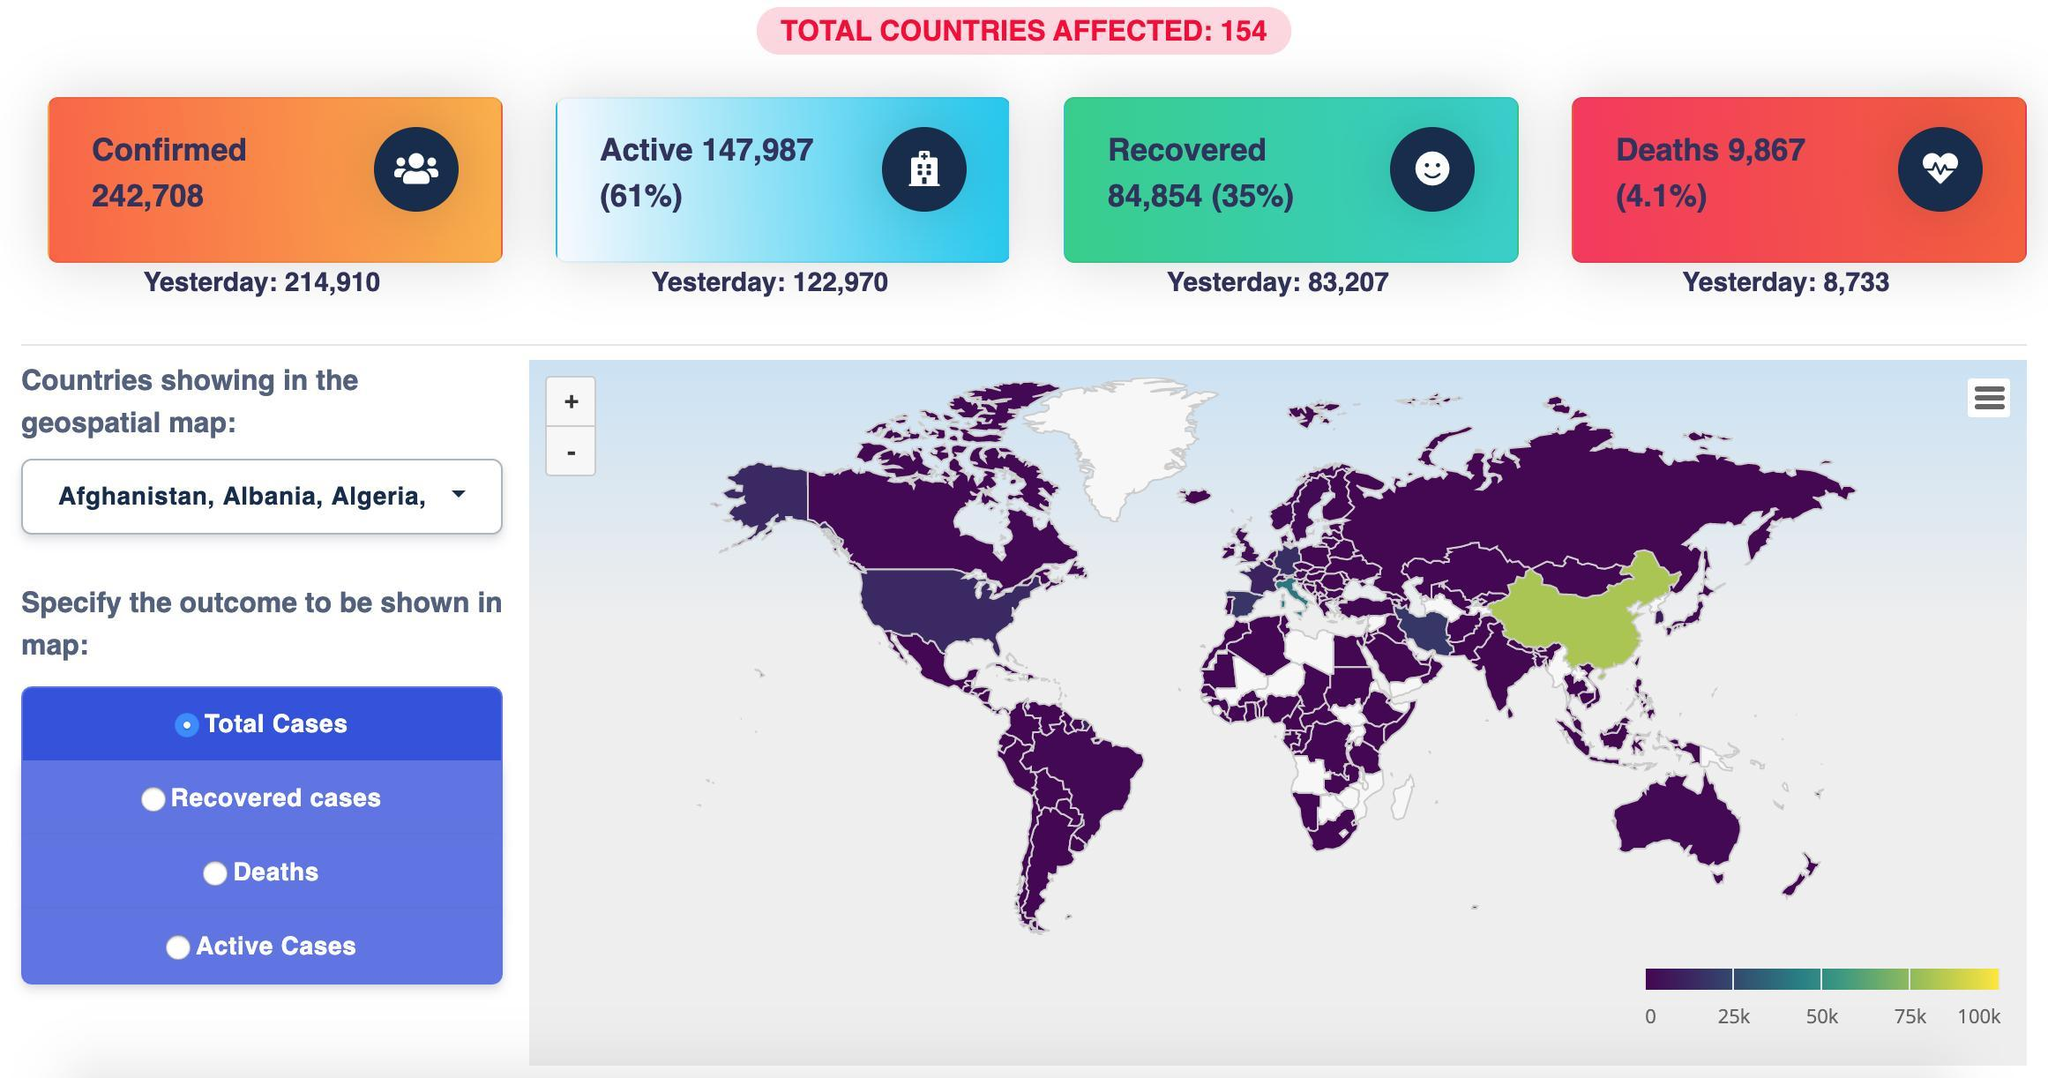How many are yet to recover
Answer the question with a short phrase. 147,987 What is the recovery rate 35% What are the total confirmed cases 242,708 Which country is shown in green, India or China China What is the death rate 4.1% 